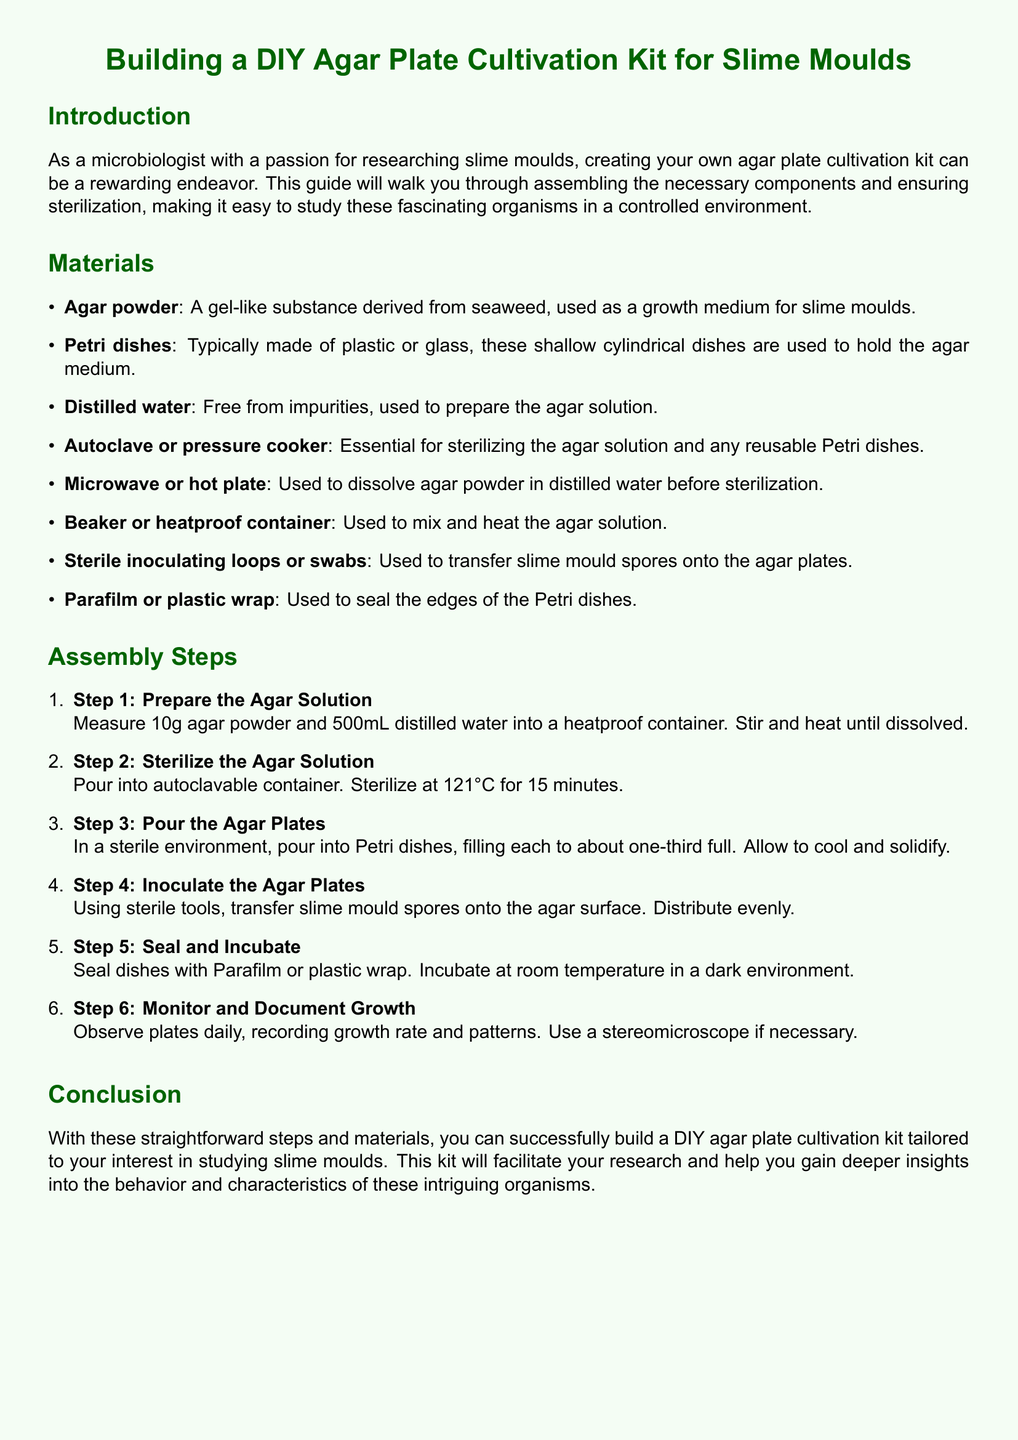what is the total amount of agar powder needed? The total amount of agar powder needed is specified in the materials section, which states 10g agar powder.
Answer: 10g how long should the agar solution be sterilized? The sterilization time for the agar solution is mentioned as 15 minutes.
Answer: 15 minutes what is used to seal the edges of the Petri dishes? The sealing material for the edges of the Petri dishes is indicated in the materials section as Parafilm or plastic wrap.
Answer: Parafilm or plastic wrap what temperature should the agar solution be sterilized at? The document specifies the sterilization temperature for the agar solution as 121°C.
Answer: 121°C what is the first step in assembling the kit? The first step in assembling the kit is detailed in the assembly steps, which states to prepare the agar solution.
Answer: Prepare the Agar Solution what should be used to observe the agar plates? The document suggests that a stereomicroscope can be used to observe the plates if necessary.
Answer: Stereomicroscope why is distilled water used in the preparation? Distilled water is used as it is free from impurities, ensuring a proper agar solution for slime moulds.
Answer: Free from impurities how full should the Petri dishes be filled with agar solution? The document indicates that the Petri dishes should be filled to about one-third full with the agar solution.
Answer: One-third full what is the incubation environment for the agar plates? The incubation environment specified for the agar plates is at room temperature in a dark environment.
Answer: Room temperature in a dark environment 